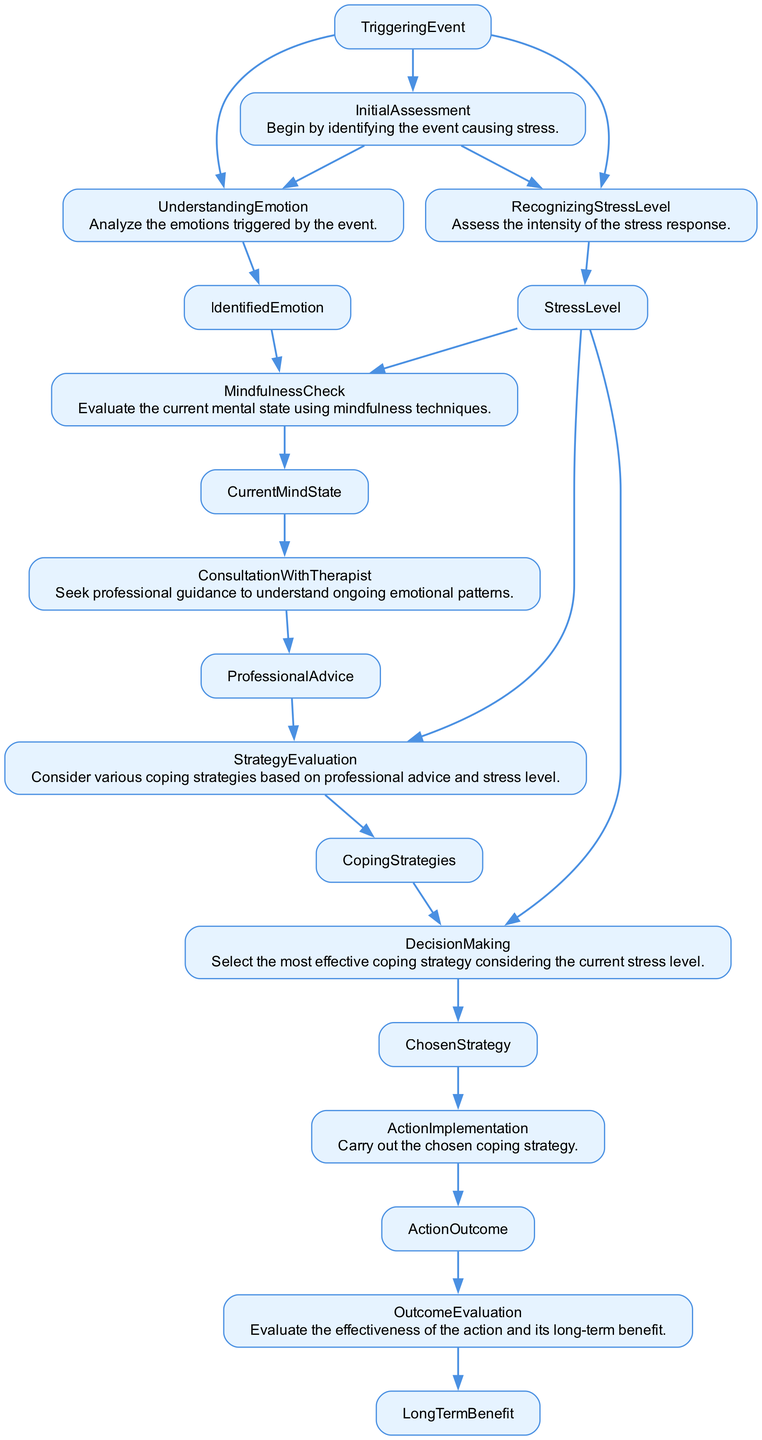What is the output of the "InitialAssessment" node? The "InitialAssessment" node outputs two items: "UnderstandingEmotion" and "RecognizingStressLevel". This is specified directly in the details of the node.
Answer: UnderstandingEmotion, RecognizingStressLevel How many outputs does the "MindfulnessCheck" node produce? The "MindfulnessCheck" node has one output, which is "CurrentMindState", as indicated by its output list.
Answer: 1 What inputs does the "StrategyEvaluation" node require? The "StrategyEvaluation" node requires two inputs: "ProfessionalAdvice" and "StressLevel", as listed in the node's input section.
Answer: ProfessionalAdvice, StressLevel What is the sequence of nodes from "InitialAssessment" to "ActionImplementation"? Starting from "InitialAssessment", the sequence of nodes is: InitialAssessment → MindfulnessCheck → ConsultationWithTherapist → StrategyEvaluation → DecisionMaking → ActionImplementation. This follows the direction of the edges connecting these nodes in the flowchart.
Answer: InitialAssessment, MindfulnessCheck, ConsultationWithTherapist, StrategyEvaluation, DecisionMaking, ActionImplementation What is the purpose of the "OutcomeEvaluation" node? The "OutcomeEvaluation" node is designed to evaluate the effectiveness of the prior actions taken and assess their long-term benefits. This is directly described in the node's purpose statement.
Answer: Evaluate effectiveness and long-term benefit What comes after "ActionImplementation" in this decision-making process? After "ActionImplementation", the next node in the process is "OutcomeEvaluation", as indicated by the directed edge leading from "ActionImplementation" to "OutcomeEvaluation".
Answer: OutcomeEvaluation Which node assesses the intensity of the stress response? The node that assesses the intensity of the stress response is "RecognizingStressLevel", as its description states that it specifically focuses on evaluating the stress response's intensity.
Answer: RecognizingStressLevel How many total nodes are involved in the decision-making process? There are nine nodes in total, specifically: InitialAssessment, UnderstandingEmotion, RecognizingStressLevel, MindfulnessCheck, ConsultationWithTherapist, StrategyEvaluation, DecisionMaking, ActionImplementation, and OutcomeEvaluation. This can be verified by counting all the nodes presented in the diagram.
Answer: 9 What does the "ConsultationWithTherapist" node provide as output? The output of the "ConsultationWithTherapist" node is "ProfessionalAdvice", as stated clearly in its output description.
Answer: ProfessionalAdvice 